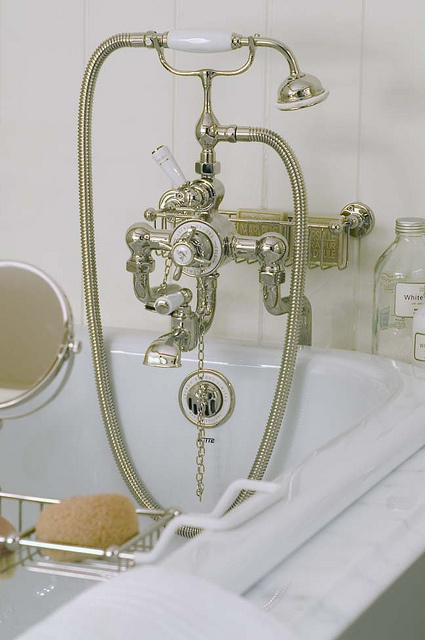Describe the objects in this image and their specific colors. I can see a bottle in lightgray, darkgray, and gray tones in this image. 